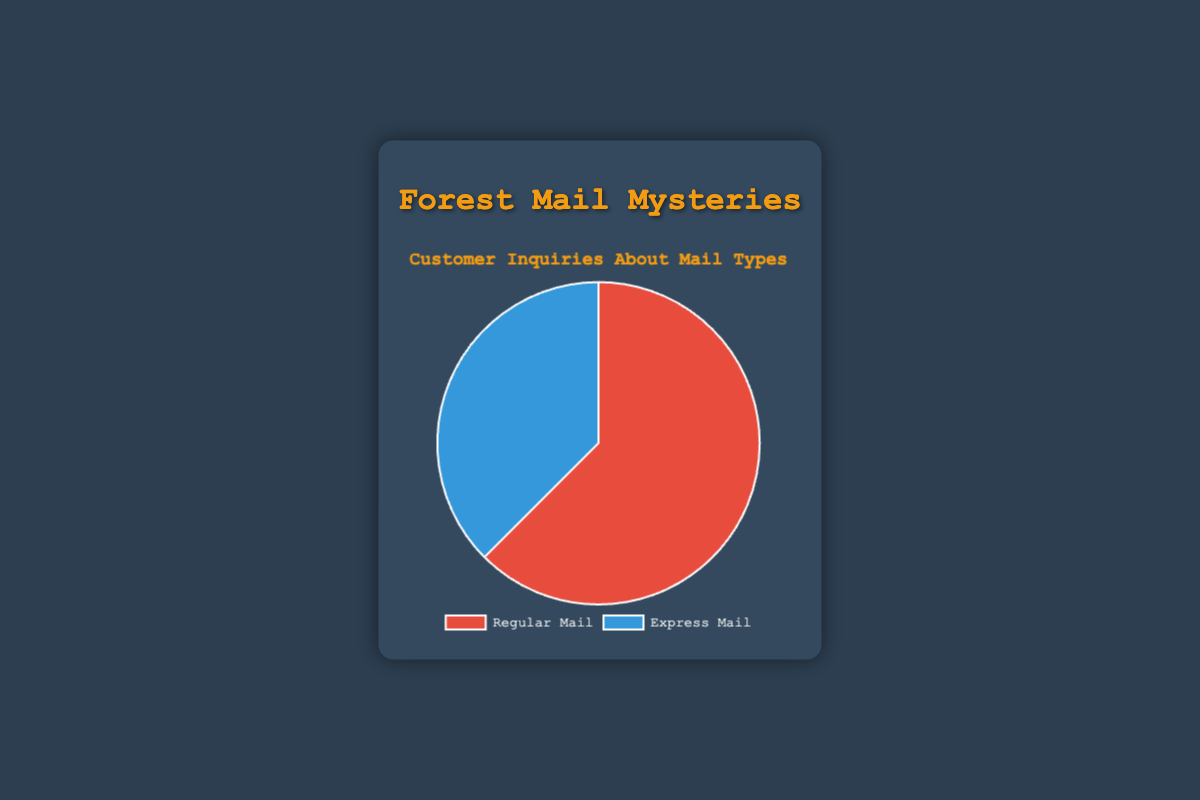What percentage of customer inquiries are about Regular Mail? To find the percentage, divide the number of inquiries for Regular Mail (1250) by the total number of inquiries (1250 + 750 = 2000), then multiply by 100. So, (1250 / 2000) * 100 = 62.5%.
Answer: 62.5% How much greater are the inquiries for Regular Mail compared to Express Mail? Subtract the number of inquiries for Express Mail (750) from the number of inquiries for Regular Mail (1250). So, 1250 - 750 = 500.
Answer: 500 What is the ratio of Regular Mail inquiries to Express Mail inquiries? Divide the number of inquiries for Regular Mail (1250) by the number of inquiries for Express Mail (750). So, 1250 / 750 = 1.67.
Answer: 1.67 Which type of mail has fewer inquiries? Compare the inquiries for Regular Mail (1250) and Express Mail (750). Express Mail has fewer inquiries.
Answer: Express Mail What fraction of the total inquiries does Express Mail represent? Divide the number of inquiries for Express Mail (750) by the total number of inquiries (2000). So, 750 / 2000 = 0.375.
Answer: 0.375 If 100 more inquiries were made for Express Mail, what would be the new percentage of inquiries for Regular Mail? First, add 100 to Express Mail inquiries (750 + 100 = 850). The new total number of inquiries is 1250 (Regular Mail) + 850 (Express Mail) = 2100. Then, divide Regular Mail inquiries by the new total and multiply by 100: (1250 / 2100) * 100 ≈ 59.52%.
Answer: 59.52% What color represents Regular Mail in the pie chart? By direct observation of the color associated with Regular Mail in the pie chart. Regular Mail is represented by the color red.
Answer: Red What is the difference in percentage points between Regular Mail and Express Mail inquiries? Find the percentage for each: Regular Mail (62.5%) and Express Mail (37.5%). Subtract Express Mail percentage from Regular Mail percentage: 62.5% - 37.5% = 25%.
Answer: 25% If inquiries for Express Mail increased by 50%, what would be the new total number of inquiries? Calculate a 50% increase for Express Mail (0.50 * 750 = 375). Add this increase to the current Express Mail inquiries (750 + 375 = 1125). The new total number of inquiries would be 1250 (Regular Mail) + 1125 (Express Mail) = 2375.
Answer: 2375 If inquiries for both types of mail doubled, what would be the new count for Regular Mail inquiries? Double the original inquiries for Regular Mail (1250 * 2 = 2500).
Answer: 2500 